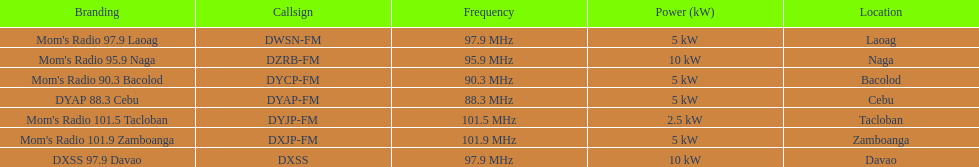What is the quantity of these stations airing at a frequency of over 100 mhz? 2. 